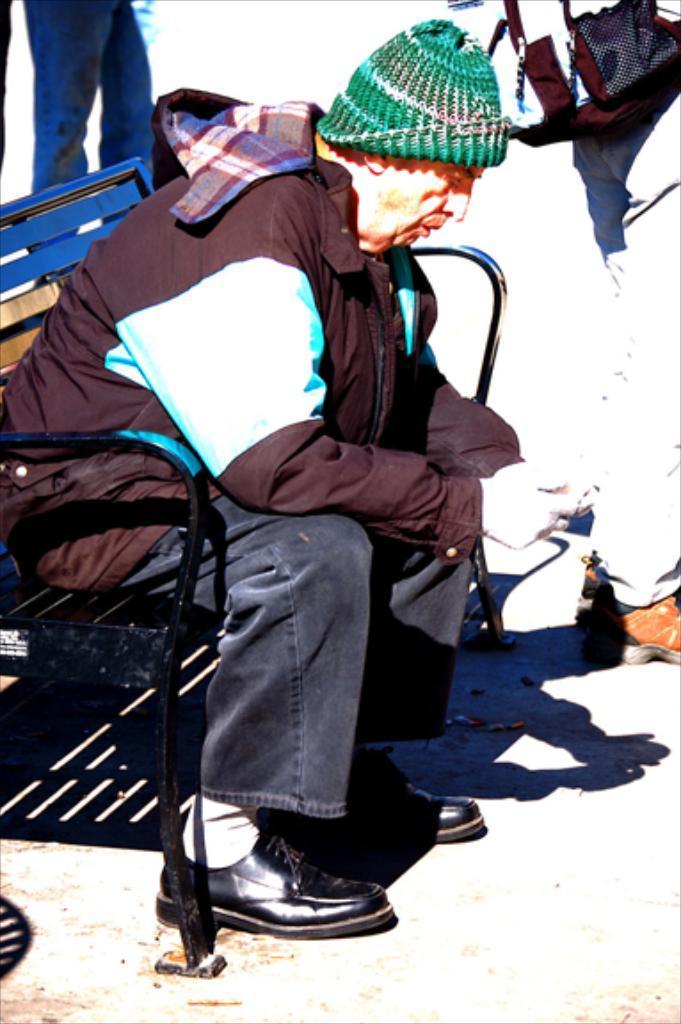Can you describe this image briefly? In this image, we can see an old person is sitting on a bench and wearing a cap. At the bottom, we can see a platform. Here we can see few human legs and bag. 